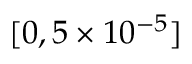Convert formula to latex. <formula><loc_0><loc_0><loc_500><loc_500>[ 0 , 5 \times 1 0 ^ { - 5 } ]</formula> 